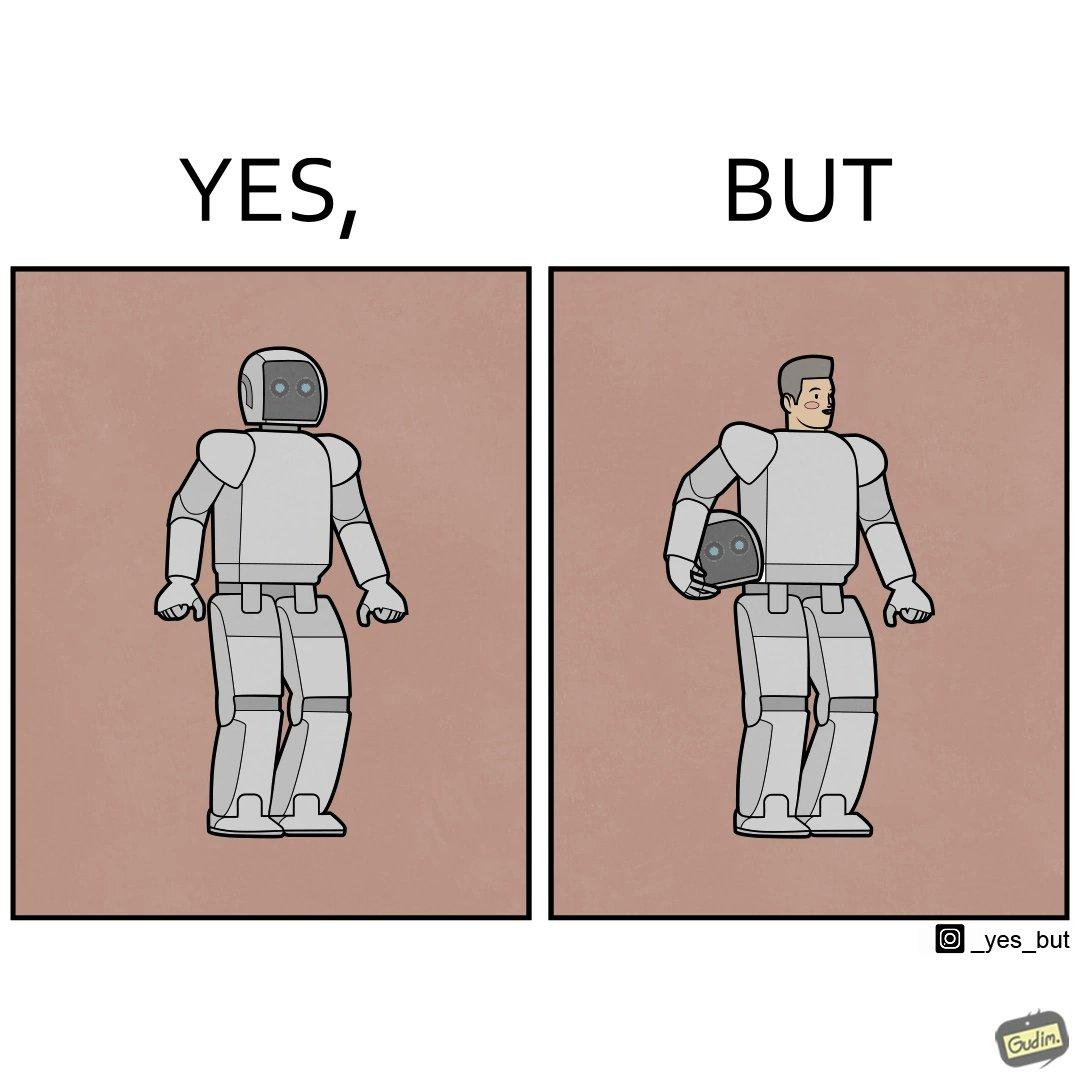Explain the humor or irony in this image. The images are ironic since we work to improve technology and build innovations like robots, but in the process we ourselves become less human and robotic in the way we function. 